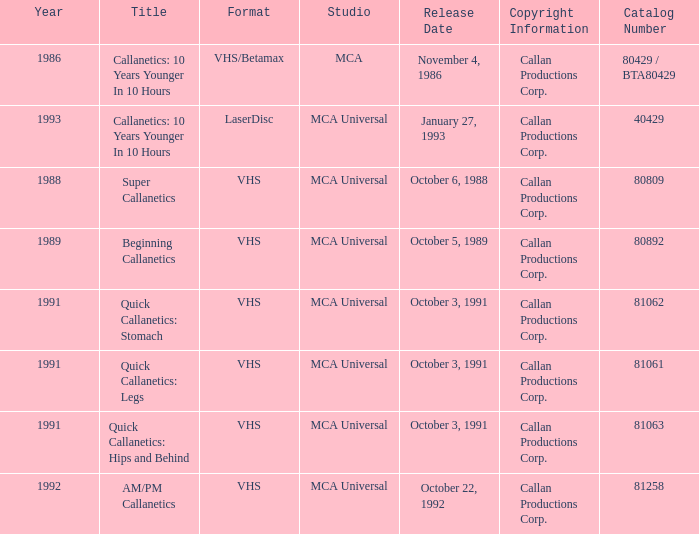Name the studio for super callanetics MCA Universal. 